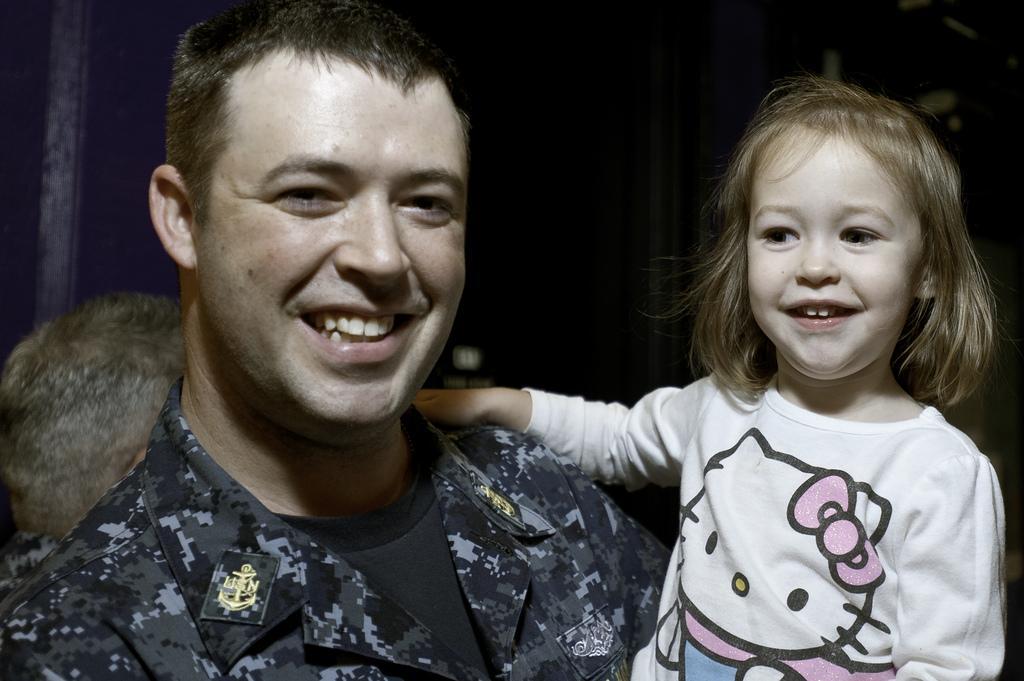Describe this image in one or two sentences. In this image I can see a man and a girl. I can see smile on their faces and I can see he is wearing uniform and she is wearing white dress. I can also see this image is little bit in dark from background. 